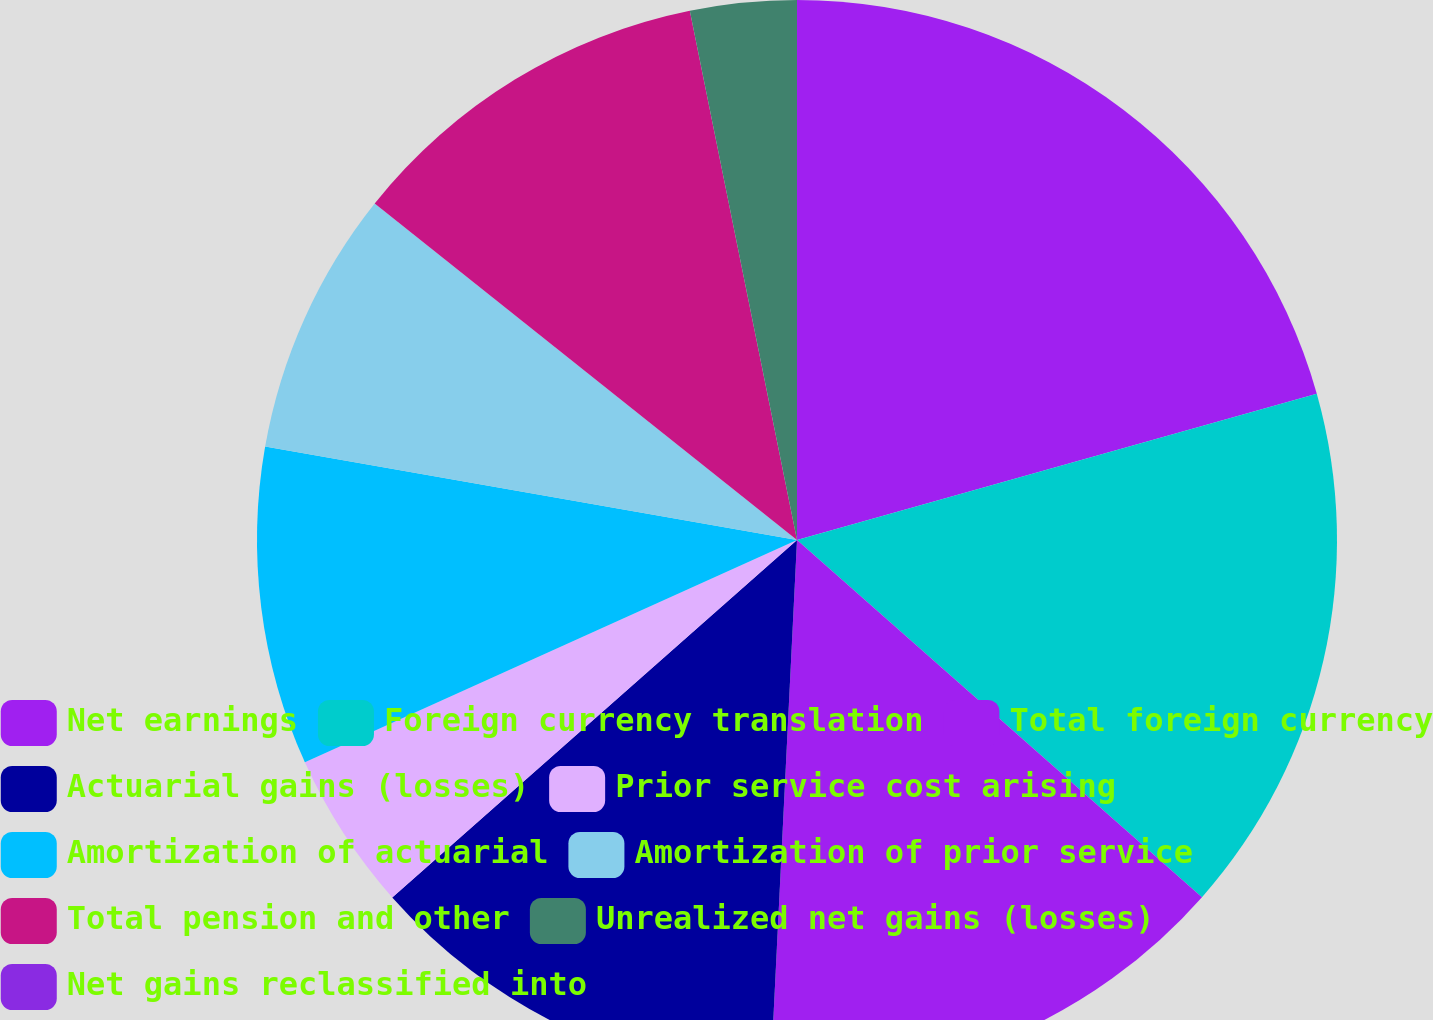Convert chart to OTSL. <chart><loc_0><loc_0><loc_500><loc_500><pie_chart><fcel>Net earnings<fcel>Foreign currency translation<fcel>Total foreign currency<fcel>Actuarial gains (losses)<fcel>Prior service cost arising<fcel>Amortization of actuarial<fcel>Amortization of prior service<fcel>Total pension and other<fcel>Unrealized net gains (losses)<fcel>Net gains reclassified into<nl><fcel>20.63%<fcel>15.87%<fcel>14.28%<fcel>12.7%<fcel>4.76%<fcel>9.52%<fcel>7.94%<fcel>11.11%<fcel>3.18%<fcel>0.0%<nl></chart> 